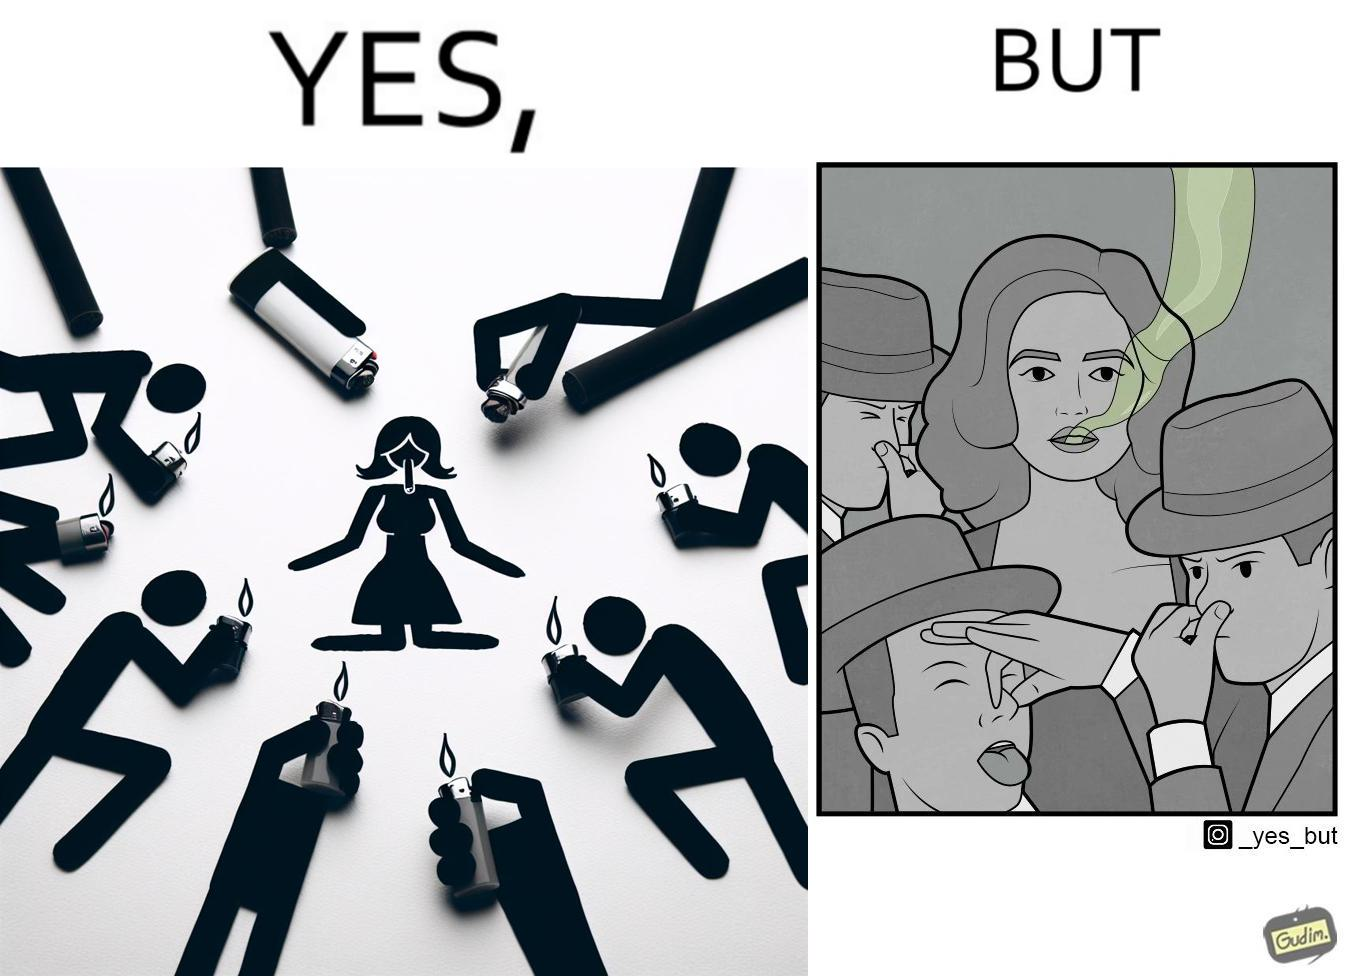Is this image satirical or non-satirical? Yes, this image is satirical. 